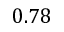<formula> <loc_0><loc_0><loc_500><loc_500>0 . 7 8</formula> 